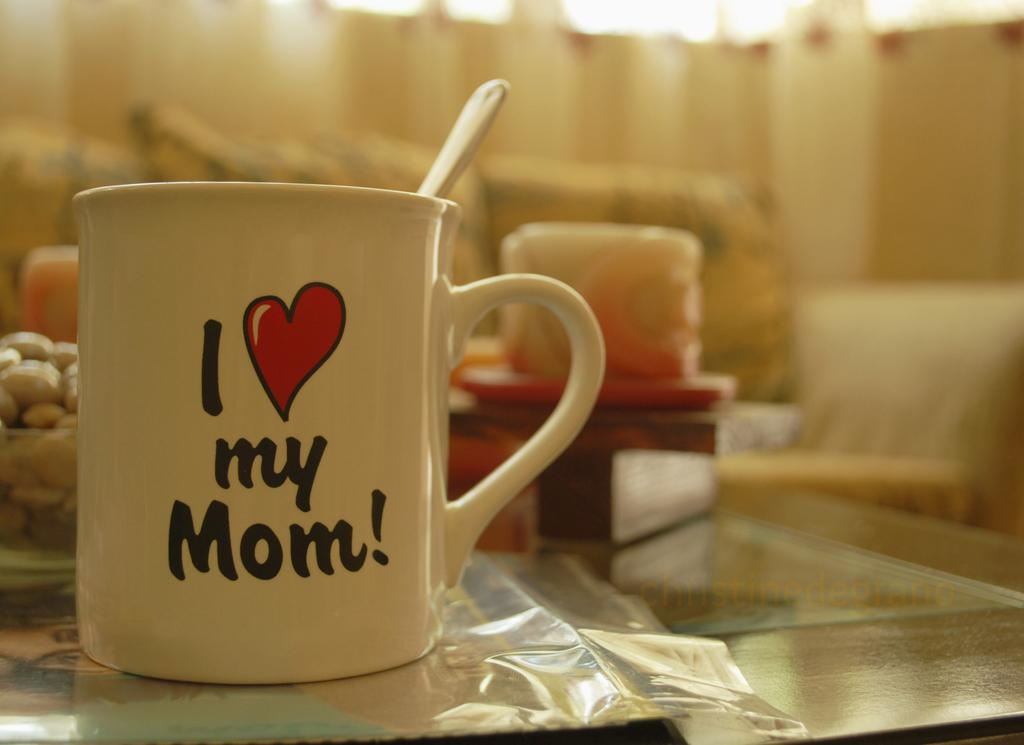What objects are inside the mug in the image? There is a spoon inside a mug in the image. Where are the spoon and mug located in relation to the image? The spoon and mug are in the foreground of the image. Can you describe the describe the background of the image? The background of the image is blurry. What type of dog is sitting at the dinner table in the image? There is no dog or dinner table present in the image; it only features a spoon inside a mug in the foreground with a blurry background. 